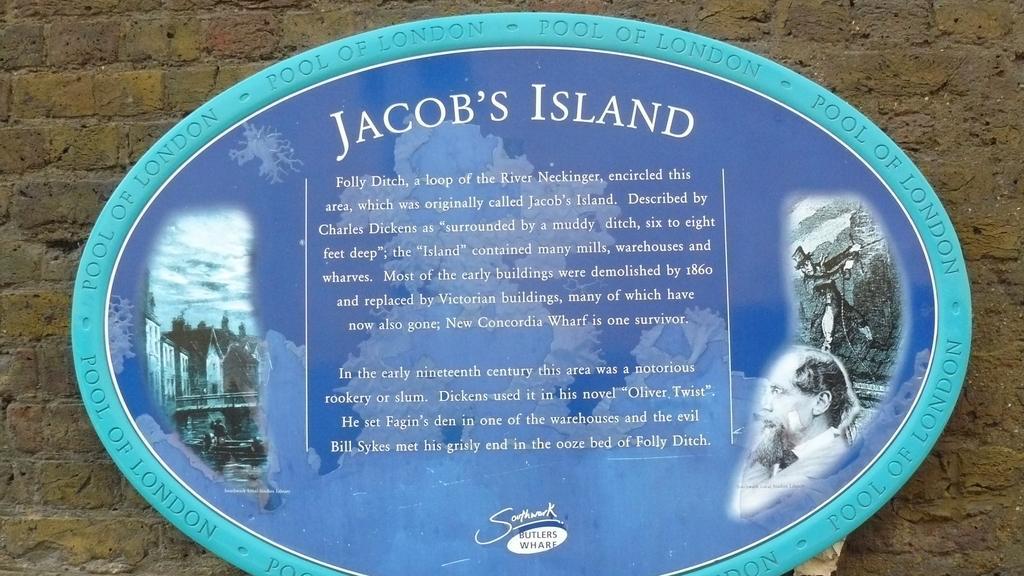Please provide a concise description of this image. In the image there is a brick wall with oval shape board. On the board there are few images. And there is something written on the board. 